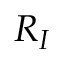<formula> <loc_0><loc_0><loc_500><loc_500>R _ { I }</formula> 